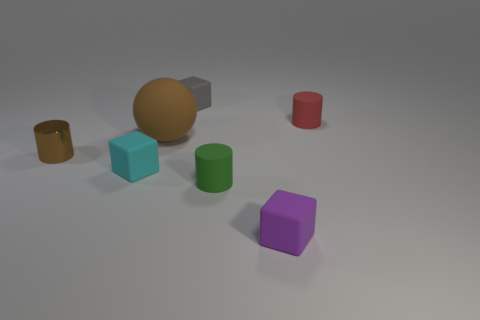What shape is the object that is in front of the small rubber cylinder in front of the brown metallic cylinder?
Provide a short and direct response. Cube. Is there any other thing that is the same shape as the big object?
Keep it short and to the point. No. Is the number of tiny metal cylinders in front of the green object the same as the number of red rubber objects?
Provide a short and direct response. No. There is a big rubber object; does it have the same color as the tiny matte cylinder that is in front of the small cyan rubber block?
Provide a succinct answer. No. What color is the tiny rubber object that is both behind the tiny cyan matte block and on the left side of the green matte cylinder?
Provide a succinct answer. Gray. What number of green matte things are on the left side of the tiny matte object behind the red cylinder?
Ensure brevity in your answer.  0. Is there another rubber thing of the same shape as the small cyan object?
Offer a very short reply. Yes. Does the brown object that is behind the tiny brown cylinder have the same shape as the metallic object behind the tiny green rubber object?
Your answer should be compact. No. How many things are big brown metallic blocks or purple blocks?
Ensure brevity in your answer.  1. There is a metallic thing that is the same shape as the tiny red matte object; what is its size?
Keep it short and to the point. Small. 